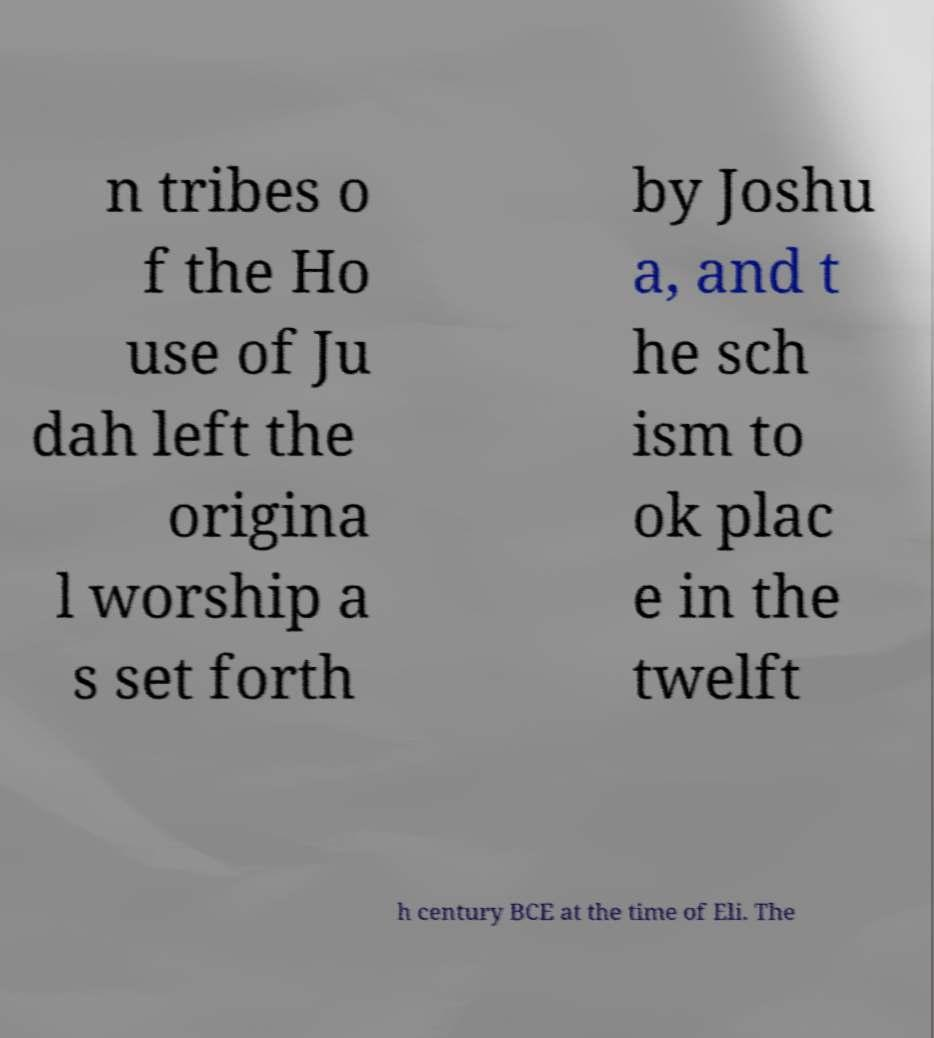Could you extract and type out the text from this image? n tribes o f the Ho use of Ju dah left the origina l worship a s set forth by Joshu a, and t he sch ism to ok plac e in the twelft h century BCE at the time of Eli. The 